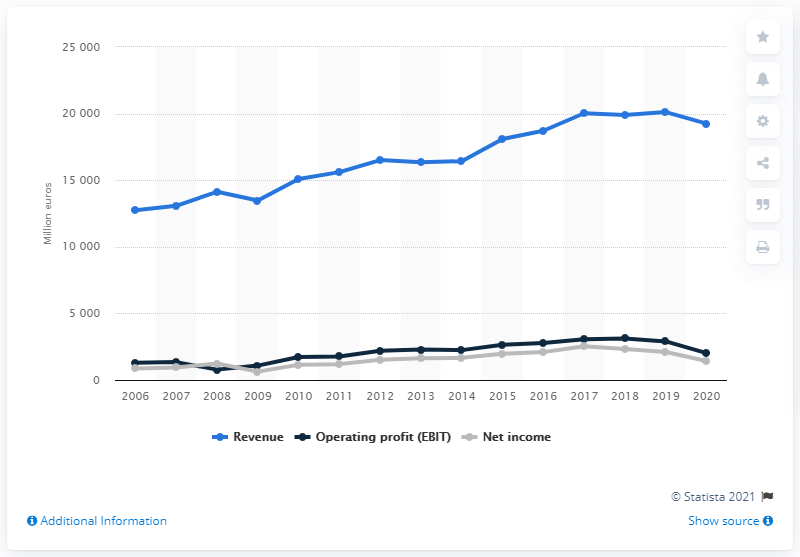Outline some significant characteristics in this image. The global operating profit of Henkel in 2020 was X. In 2006, the global operating profit of Henkel was Y. 